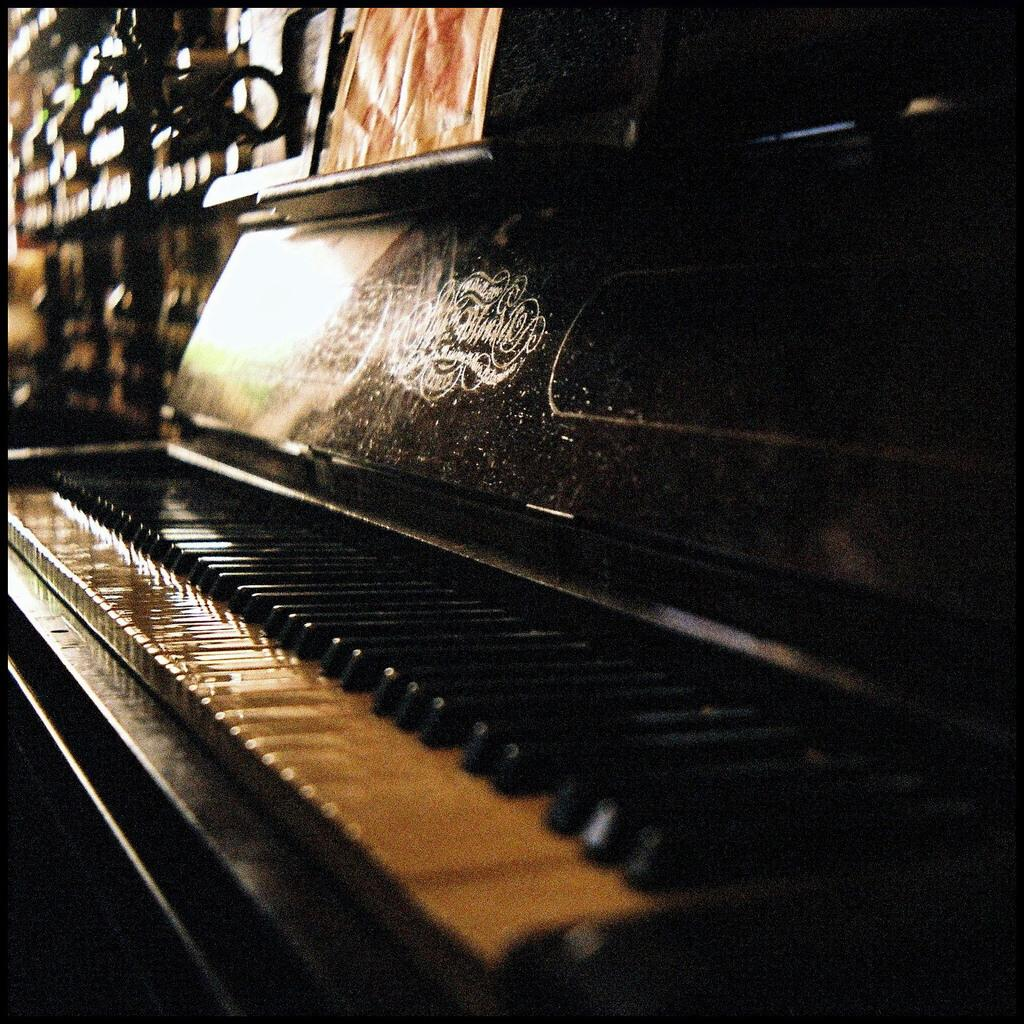What is the main object in the picture? There is a piano in the picture. What can be observed about the piano's appearance? The piano has patterns on it. How does the lighting affect the appearance of the piano keys? The white keys appear pale yellow due to the darkness. What type of drug is visible on the piano keys in the image? There is no drug present on the piano keys in the image. Can you see any zebras playing the piano in the image? There are no zebras present in the image, and they are not playing the piano. 